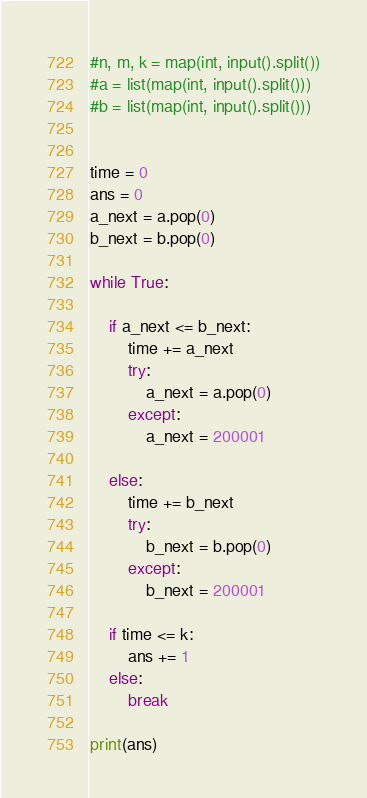<code> <loc_0><loc_0><loc_500><loc_500><_Python_>#n, m, k = map(int, input().split())
#a = list(map(int, input().split()))
#b = list(map(int, input().split()))


time = 0
ans = 0
a_next = a.pop(0)
b_next = b.pop(0)

while True:
        
    if a_next <= b_next:
        time += a_next
        try:
            a_next = a.pop(0)
        except:
            a_next = 200001
    
    else:
        time += b_next
        try:
            b_next = b.pop(0)
        except:
            b_next = 200001
    
    if time <= k:
        ans += 1
    else:
        break

print(ans)</code> 